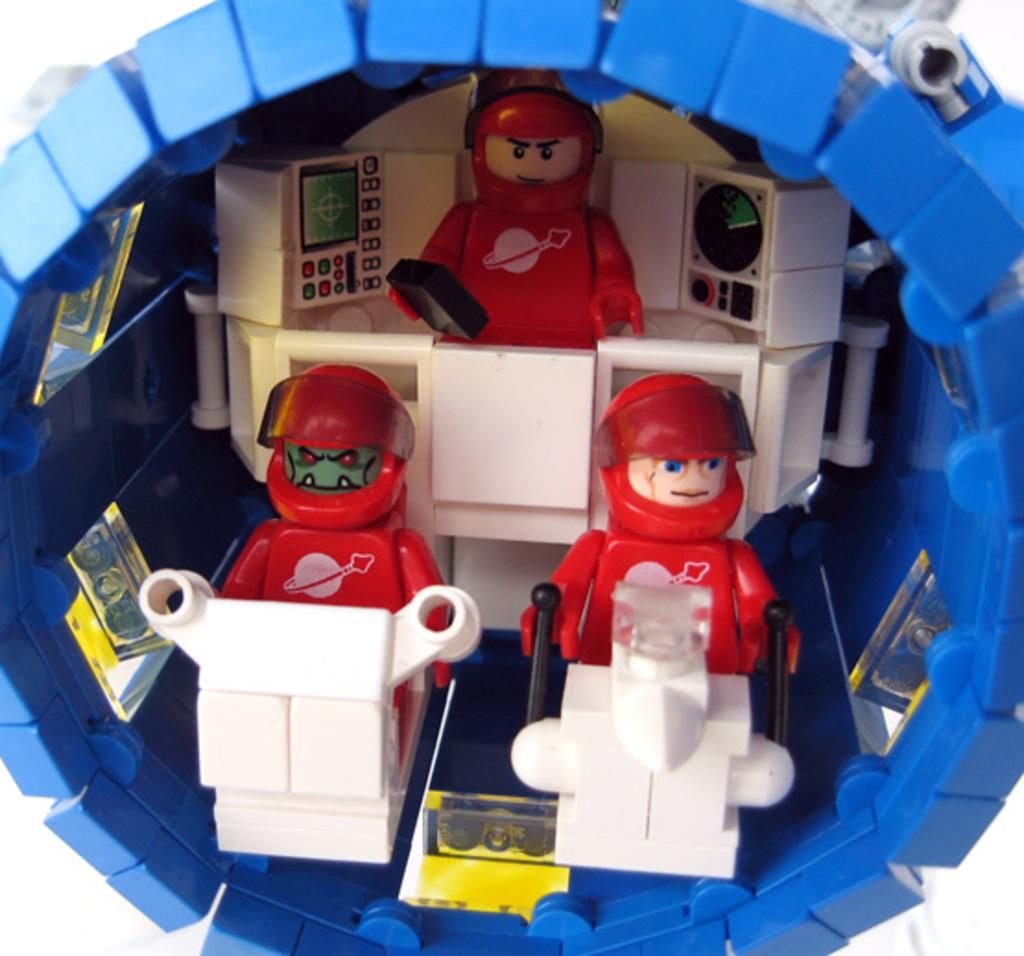What type of objects can be seen in the image? There are toys in the image. What type of sun can be seen in the image? There is no sun present in the image; it features toys. What type of carriage is being pulled by the toys in the image? There is no carriage present in the image; it features toys without any specific vehicles or objects being pulled. 